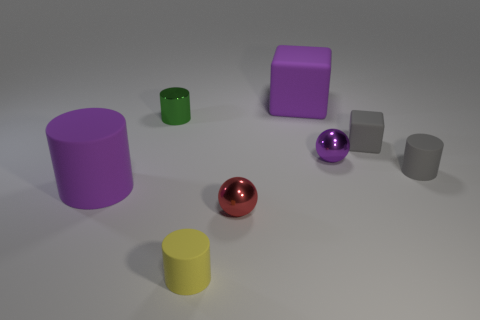Add 2 gray objects. How many objects exist? 10 Subtract all spheres. How many objects are left? 6 Subtract all purple metal balls. Subtract all large purple rubber things. How many objects are left? 5 Add 8 red things. How many red things are left? 9 Add 1 yellow matte cylinders. How many yellow matte cylinders exist? 2 Subtract 1 purple spheres. How many objects are left? 7 